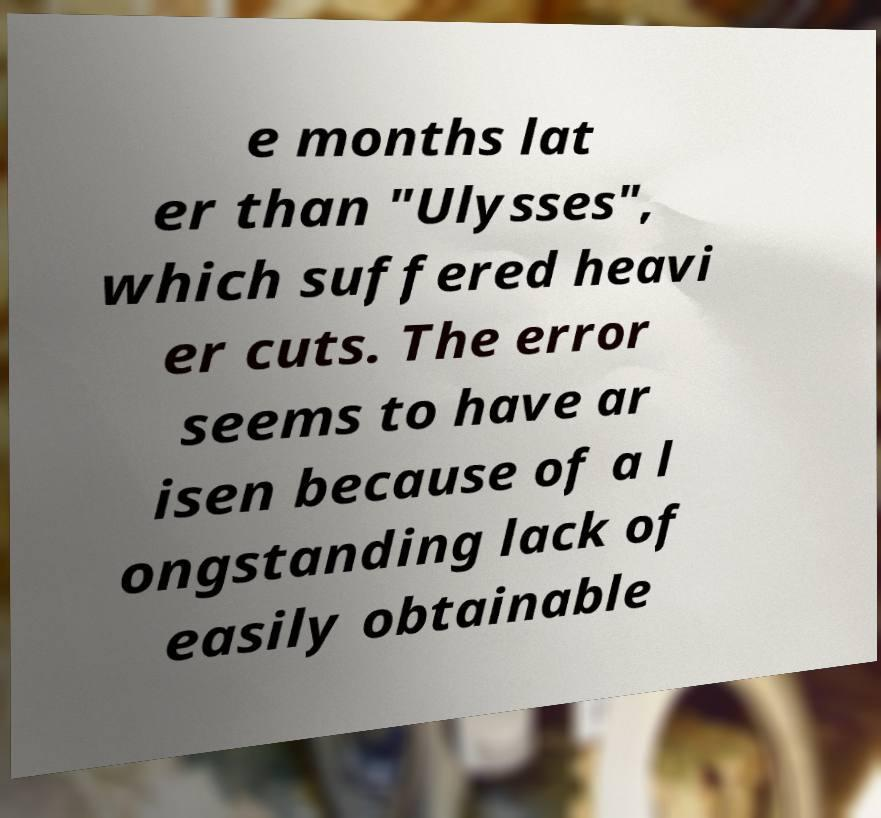For documentation purposes, I need the text within this image transcribed. Could you provide that? e months lat er than "Ulysses", which suffered heavi er cuts. The error seems to have ar isen because of a l ongstanding lack of easily obtainable 